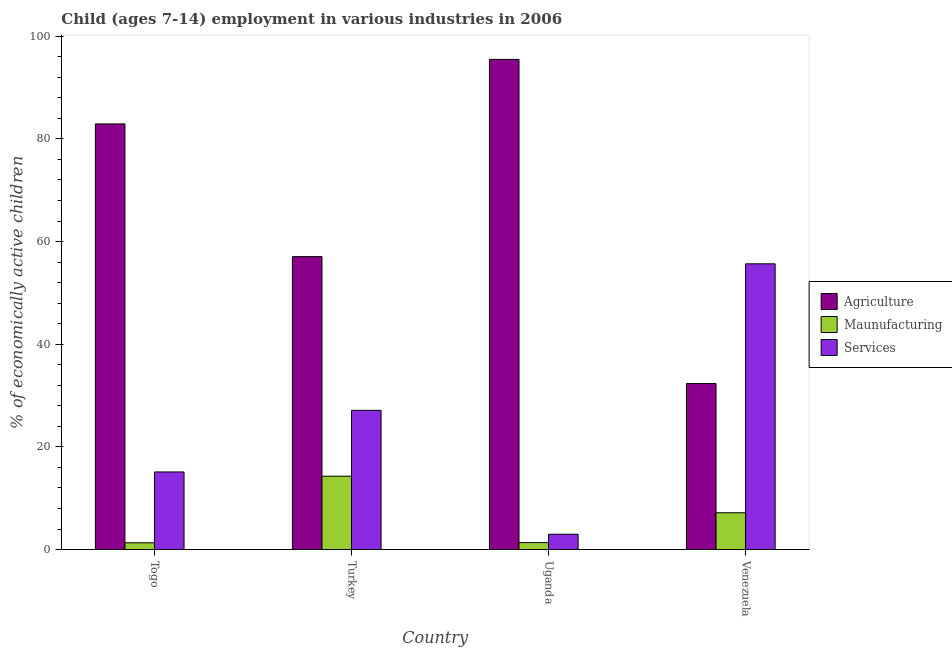How many different coloured bars are there?
Offer a terse response. 3. Are the number of bars on each tick of the X-axis equal?
Offer a very short reply. Yes. How many bars are there on the 3rd tick from the right?
Your response must be concise. 3. What is the label of the 2nd group of bars from the left?
Offer a terse response. Turkey. In how many cases, is the number of bars for a given country not equal to the number of legend labels?
Provide a succinct answer. 0. What is the percentage of economically active children in manufacturing in Uganda?
Your answer should be compact. 1.36. Across all countries, what is the maximum percentage of economically active children in manufacturing?
Your response must be concise. 14.29. Across all countries, what is the minimum percentage of economically active children in manufacturing?
Provide a short and direct response. 1.32. In which country was the percentage of economically active children in agriculture maximum?
Offer a terse response. Uganda. In which country was the percentage of economically active children in agriculture minimum?
Keep it short and to the point. Venezuela. What is the total percentage of economically active children in agriculture in the graph?
Offer a very short reply. 267.79. What is the difference between the percentage of economically active children in services in Uganda and that in Venezuela?
Your answer should be compact. -52.67. What is the difference between the percentage of economically active children in services in Uganda and the percentage of economically active children in manufacturing in Turkey?
Your answer should be very brief. -11.3. What is the average percentage of economically active children in manufacturing per country?
Give a very brief answer. 6.04. What is the difference between the percentage of economically active children in manufacturing and percentage of economically active children in services in Venezuela?
Ensure brevity in your answer.  -48.49. What is the ratio of the percentage of economically active children in services in Togo to that in Venezuela?
Offer a terse response. 0.27. Is the percentage of economically active children in manufacturing in Turkey less than that in Venezuela?
Make the answer very short. No. What is the difference between the highest and the second highest percentage of economically active children in services?
Provide a succinct answer. 28.54. What is the difference between the highest and the lowest percentage of economically active children in services?
Keep it short and to the point. 52.67. Is the sum of the percentage of economically active children in agriculture in Togo and Venezuela greater than the maximum percentage of economically active children in services across all countries?
Your response must be concise. Yes. What does the 2nd bar from the left in Turkey represents?
Give a very brief answer. Maunufacturing. What does the 3rd bar from the right in Togo represents?
Provide a succinct answer. Agriculture. Is it the case that in every country, the sum of the percentage of economically active children in agriculture and percentage of economically active children in manufacturing is greater than the percentage of economically active children in services?
Make the answer very short. No. How many countries are there in the graph?
Your answer should be compact. 4. Are the values on the major ticks of Y-axis written in scientific E-notation?
Give a very brief answer. No. How are the legend labels stacked?
Provide a short and direct response. Vertical. What is the title of the graph?
Give a very brief answer. Child (ages 7-14) employment in various industries in 2006. Does "Capital account" appear as one of the legend labels in the graph?
Keep it short and to the point. No. What is the label or title of the X-axis?
Your answer should be very brief. Country. What is the label or title of the Y-axis?
Ensure brevity in your answer.  % of economically active children. What is the % of economically active children of Agriculture in Togo?
Ensure brevity in your answer.  82.91. What is the % of economically active children of Maunufacturing in Togo?
Offer a terse response. 1.32. What is the % of economically active children of Services in Togo?
Your answer should be very brief. 15.12. What is the % of economically active children in Agriculture in Turkey?
Make the answer very short. 57.06. What is the % of economically active children of Maunufacturing in Turkey?
Provide a succinct answer. 14.29. What is the % of economically active children of Services in Turkey?
Your answer should be very brief. 27.12. What is the % of economically active children in Agriculture in Uganda?
Ensure brevity in your answer.  95.48. What is the % of economically active children of Maunufacturing in Uganda?
Offer a terse response. 1.36. What is the % of economically active children of Services in Uganda?
Provide a succinct answer. 2.99. What is the % of economically active children in Agriculture in Venezuela?
Provide a short and direct response. 32.34. What is the % of economically active children of Maunufacturing in Venezuela?
Keep it short and to the point. 7.17. What is the % of economically active children of Services in Venezuela?
Provide a short and direct response. 55.66. Across all countries, what is the maximum % of economically active children of Agriculture?
Offer a terse response. 95.48. Across all countries, what is the maximum % of economically active children of Maunufacturing?
Make the answer very short. 14.29. Across all countries, what is the maximum % of economically active children in Services?
Offer a very short reply. 55.66. Across all countries, what is the minimum % of economically active children of Agriculture?
Keep it short and to the point. 32.34. Across all countries, what is the minimum % of economically active children in Maunufacturing?
Your answer should be compact. 1.32. Across all countries, what is the minimum % of economically active children of Services?
Give a very brief answer. 2.99. What is the total % of economically active children in Agriculture in the graph?
Provide a succinct answer. 267.79. What is the total % of economically active children in Maunufacturing in the graph?
Keep it short and to the point. 24.14. What is the total % of economically active children of Services in the graph?
Provide a succinct answer. 100.89. What is the difference between the % of economically active children in Agriculture in Togo and that in Turkey?
Offer a terse response. 25.85. What is the difference between the % of economically active children in Maunufacturing in Togo and that in Turkey?
Keep it short and to the point. -12.97. What is the difference between the % of economically active children in Services in Togo and that in Turkey?
Offer a terse response. -12. What is the difference between the % of economically active children of Agriculture in Togo and that in Uganda?
Your answer should be compact. -12.57. What is the difference between the % of economically active children of Maunufacturing in Togo and that in Uganda?
Offer a terse response. -0.04. What is the difference between the % of economically active children in Services in Togo and that in Uganda?
Offer a very short reply. 12.13. What is the difference between the % of economically active children of Agriculture in Togo and that in Venezuela?
Your response must be concise. 50.57. What is the difference between the % of economically active children of Maunufacturing in Togo and that in Venezuela?
Give a very brief answer. -5.85. What is the difference between the % of economically active children of Services in Togo and that in Venezuela?
Provide a short and direct response. -40.54. What is the difference between the % of economically active children of Agriculture in Turkey and that in Uganda?
Your answer should be compact. -38.42. What is the difference between the % of economically active children of Maunufacturing in Turkey and that in Uganda?
Ensure brevity in your answer.  12.93. What is the difference between the % of economically active children in Services in Turkey and that in Uganda?
Offer a terse response. 24.13. What is the difference between the % of economically active children of Agriculture in Turkey and that in Venezuela?
Ensure brevity in your answer.  24.72. What is the difference between the % of economically active children in Maunufacturing in Turkey and that in Venezuela?
Provide a succinct answer. 7.12. What is the difference between the % of economically active children of Services in Turkey and that in Venezuela?
Your answer should be compact. -28.54. What is the difference between the % of economically active children in Agriculture in Uganda and that in Venezuela?
Your response must be concise. 63.14. What is the difference between the % of economically active children in Maunufacturing in Uganda and that in Venezuela?
Your response must be concise. -5.81. What is the difference between the % of economically active children of Services in Uganda and that in Venezuela?
Provide a short and direct response. -52.67. What is the difference between the % of economically active children of Agriculture in Togo and the % of economically active children of Maunufacturing in Turkey?
Keep it short and to the point. 68.62. What is the difference between the % of economically active children of Agriculture in Togo and the % of economically active children of Services in Turkey?
Ensure brevity in your answer.  55.79. What is the difference between the % of economically active children in Maunufacturing in Togo and the % of economically active children in Services in Turkey?
Your response must be concise. -25.8. What is the difference between the % of economically active children in Agriculture in Togo and the % of economically active children in Maunufacturing in Uganda?
Give a very brief answer. 81.55. What is the difference between the % of economically active children in Agriculture in Togo and the % of economically active children in Services in Uganda?
Keep it short and to the point. 79.92. What is the difference between the % of economically active children of Maunufacturing in Togo and the % of economically active children of Services in Uganda?
Your answer should be very brief. -1.67. What is the difference between the % of economically active children of Agriculture in Togo and the % of economically active children of Maunufacturing in Venezuela?
Provide a short and direct response. 75.74. What is the difference between the % of economically active children in Agriculture in Togo and the % of economically active children in Services in Venezuela?
Ensure brevity in your answer.  27.25. What is the difference between the % of economically active children of Maunufacturing in Togo and the % of economically active children of Services in Venezuela?
Your answer should be compact. -54.34. What is the difference between the % of economically active children of Agriculture in Turkey and the % of economically active children of Maunufacturing in Uganda?
Keep it short and to the point. 55.7. What is the difference between the % of economically active children in Agriculture in Turkey and the % of economically active children in Services in Uganda?
Your answer should be compact. 54.07. What is the difference between the % of economically active children of Maunufacturing in Turkey and the % of economically active children of Services in Uganda?
Provide a short and direct response. 11.3. What is the difference between the % of economically active children in Agriculture in Turkey and the % of economically active children in Maunufacturing in Venezuela?
Your response must be concise. 49.89. What is the difference between the % of economically active children in Maunufacturing in Turkey and the % of economically active children in Services in Venezuela?
Give a very brief answer. -41.37. What is the difference between the % of economically active children in Agriculture in Uganda and the % of economically active children in Maunufacturing in Venezuela?
Provide a succinct answer. 88.31. What is the difference between the % of economically active children of Agriculture in Uganda and the % of economically active children of Services in Venezuela?
Provide a short and direct response. 39.82. What is the difference between the % of economically active children of Maunufacturing in Uganda and the % of economically active children of Services in Venezuela?
Your response must be concise. -54.3. What is the average % of economically active children of Agriculture per country?
Make the answer very short. 66.95. What is the average % of economically active children in Maunufacturing per country?
Offer a very short reply. 6.04. What is the average % of economically active children in Services per country?
Your answer should be very brief. 25.22. What is the difference between the % of economically active children of Agriculture and % of economically active children of Maunufacturing in Togo?
Provide a succinct answer. 81.59. What is the difference between the % of economically active children of Agriculture and % of economically active children of Services in Togo?
Your answer should be very brief. 67.79. What is the difference between the % of economically active children of Maunufacturing and % of economically active children of Services in Togo?
Your answer should be very brief. -13.8. What is the difference between the % of economically active children of Agriculture and % of economically active children of Maunufacturing in Turkey?
Provide a succinct answer. 42.77. What is the difference between the % of economically active children of Agriculture and % of economically active children of Services in Turkey?
Give a very brief answer. 29.94. What is the difference between the % of economically active children in Maunufacturing and % of economically active children in Services in Turkey?
Your answer should be compact. -12.83. What is the difference between the % of economically active children in Agriculture and % of economically active children in Maunufacturing in Uganda?
Keep it short and to the point. 94.12. What is the difference between the % of economically active children of Agriculture and % of economically active children of Services in Uganda?
Ensure brevity in your answer.  92.49. What is the difference between the % of economically active children in Maunufacturing and % of economically active children in Services in Uganda?
Provide a succinct answer. -1.63. What is the difference between the % of economically active children of Agriculture and % of economically active children of Maunufacturing in Venezuela?
Your answer should be very brief. 25.17. What is the difference between the % of economically active children in Agriculture and % of economically active children in Services in Venezuela?
Your answer should be compact. -23.32. What is the difference between the % of economically active children of Maunufacturing and % of economically active children of Services in Venezuela?
Make the answer very short. -48.49. What is the ratio of the % of economically active children in Agriculture in Togo to that in Turkey?
Your answer should be compact. 1.45. What is the ratio of the % of economically active children of Maunufacturing in Togo to that in Turkey?
Ensure brevity in your answer.  0.09. What is the ratio of the % of economically active children of Services in Togo to that in Turkey?
Your answer should be compact. 0.56. What is the ratio of the % of economically active children of Agriculture in Togo to that in Uganda?
Ensure brevity in your answer.  0.87. What is the ratio of the % of economically active children in Maunufacturing in Togo to that in Uganda?
Make the answer very short. 0.97. What is the ratio of the % of economically active children of Services in Togo to that in Uganda?
Make the answer very short. 5.06. What is the ratio of the % of economically active children in Agriculture in Togo to that in Venezuela?
Your response must be concise. 2.56. What is the ratio of the % of economically active children of Maunufacturing in Togo to that in Venezuela?
Keep it short and to the point. 0.18. What is the ratio of the % of economically active children of Services in Togo to that in Venezuela?
Give a very brief answer. 0.27. What is the ratio of the % of economically active children in Agriculture in Turkey to that in Uganda?
Offer a very short reply. 0.6. What is the ratio of the % of economically active children of Maunufacturing in Turkey to that in Uganda?
Provide a succinct answer. 10.51. What is the ratio of the % of economically active children in Services in Turkey to that in Uganda?
Provide a short and direct response. 9.07. What is the ratio of the % of economically active children in Agriculture in Turkey to that in Venezuela?
Offer a terse response. 1.76. What is the ratio of the % of economically active children in Maunufacturing in Turkey to that in Venezuela?
Offer a terse response. 1.99. What is the ratio of the % of economically active children of Services in Turkey to that in Venezuela?
Ensure brevity in your answer.  0.49. What is the ratio of the % of economically active children in Agriculture in Uganda to that in Venezuela?
Your answer should be compact. 2.95. What is the ratio of the % of economically active children of Maunufacturing in Uganda to that in Venezuela?
Your answer should be compact. 0.19. What is the ratio of the % of economically active children in Services in Uganda to that in Venezuela?
Your answer should be very brief. 0.05. What is the difference between the highest and the second highest % of economically active children of Agriculture?
Provide a short and direct response. 12.57. What is the difference between the highest and the second highest % of economically active children of Maunufacturing?
Your response must be concise. 7.12. What is the difference between the highest and the second highest % of economically active children in Services?
Offer a terse response. 28.54. What is the difference between the highest and the lowest % of economically active children in Agriculture?
Keep it short and to the point. 63.14. What is the difference between the highest and the lowest % of economically active children of Maunufacturing?
Your answer should be very brief. 12.97. What is the difference between the highest and the lowest % of economically active children of Services?
Your response must be concise. 52.67. 